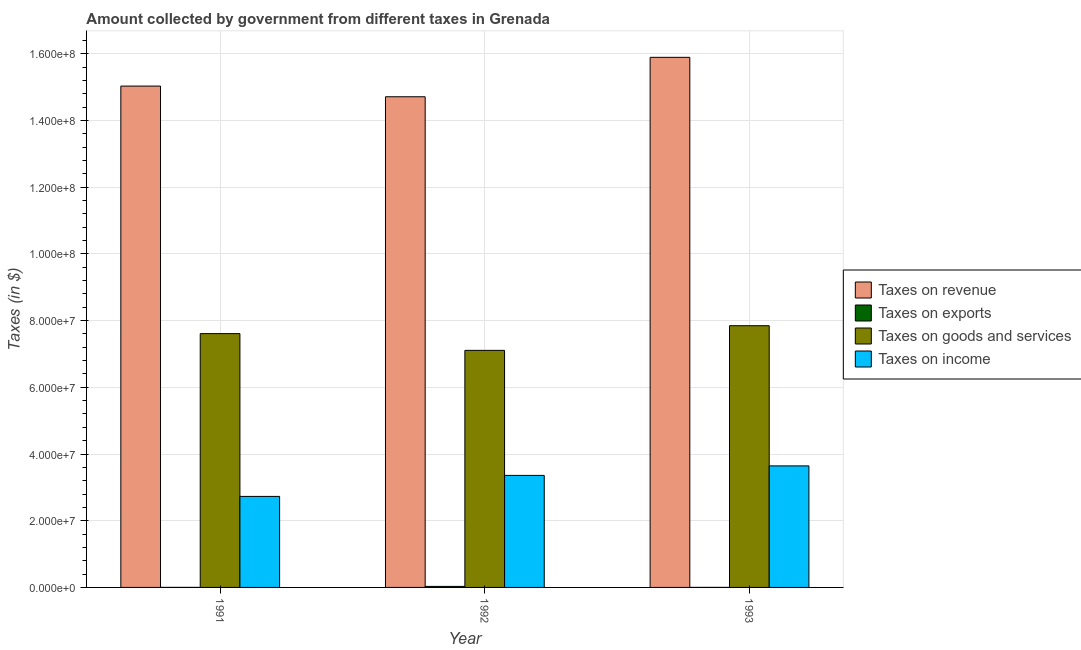How many different coloured bars are there?
Keep it short and to the point. 4. How many bars are there on the 2nd tick from the right?
Your answer should be very brief. 4. In how many cases, is the number of bars for a given year not equal to the number of legend labels?
Your response must be concise. 0. What is the amount collected as tax on goods in 1993?
Your answer should be very brief. 7.85e+07. Across all years, what is the maximum amount collected as tax on goods?
Ensure brevity in your answer.  7.85e+07. Across all years, what is the minimum amount collected as tax on goods?
Provide a short and direct response. 7.11e+07. In which year was the amount collected as tax on income minimum?
Offer a very short reply. 1991. What is the total amount collected as tax on exports in the graph?
Offer a very short reply. 3.30e+05. What is the difference between the amount collected as tax on goods in 1991 and that in 1993?
Offer a very short reply. -2.37e+06. What is the difference between the amount collected as tax on income in 1992 and the amount collected as tax on goods in 1993?
Ensure brevity in your answer.  -2.85e+06. What is the average amount collected as tax on revenue per year?
Keep it short and to the point. 1.52e+08. In how many years, is the amount collected as tax on revenue greater than 120000000 $?
Make the answer very short. 3. What is the ratio of the amount collected as tax on exports in 1991 to that in 1993?
Give a very brief answer. 1. Is the difference between the amount collected as tax on revenue in 1991 and 1992 greater than the difference between the amount collected as tax on exports in 1991 and 1992?
Keep it short and to the point. No. What is the difference between the highest and the lowest amount collected as tax on income?
Your response must be concise. 9.15e+06. In how many years, is the amount collected as tax on goods greater than the average amount collected as tax on goods taken over all years?
Your answer should be very brief. 2. What does the 4th bar from the left in 1993 represents?
Keep it short and to the point. Taxes on income. What does the 3rd bar from the right in 1992 represents?
Keep it short and to the point. Taxes on exports. How many bars are there?
Offer a very short reply. 12. Does the graph contain grids?
Provide a succinct answer. Yes. What is the title of the graph?
Provide a succinct answer. Amount collected by government from different taxes in Grenada. What is the label or title of the X-axis?
Your answer should be compact. Year. What is the label or title of the Y-axis?
Your response must be concise. Taxes (in $). What is the Taxes (in $) in Taxes on revenue in 1991?
Provide a succinct answer. 1.50e+08. What is the Taxes (in $) in Taxes on exports in 1991?
Provide a succinct answer. 10000. What is the Taxes (in $) in Taxes on goods and services in 1991?
Your answer should be very brief. 7.61e+07. What is the Taxes (in $) in Taxes on income in 1991?
Give a very brief answer. 2.73e+07. What is the Taxes (in $) of Taxes on revenue in 1992?
Your response must be concise. 1.47e+08. What is the Taxes (in $) of Taxes on goods and services in 1992?
Offer a very short reply. 7.11e+07. What is the Taxes (in $) in Taxes on income in 1992?
Provide a short and direct response. 3.36e+07. What is the Taxes (in $) of Taxes on revenue in 1993?
Keep it short and to the point. 1.59e+08. What is the Taxes (in $) of Taxes on exports in 1993?
Provide a succinct answer. 10000. What is the Taxes (in $) in Taxes on goods and services in 1993?
Keep it short and to the point. 7.85e+07. What is the Taxes (in $) in Taxes on income in 1993?
Offer a very short reply. 3.64e+07. Across all years, what is the maximum Taxes (in $) in Taxes on revenue?
Give a very brief answer. 1.59e+08. Across all years, what is the maximum Taxes (in $) of Taxes on exports?
Keep it short and to the point. 3.10e+05. Across all years, what is the maximum Taxes (in $) in Taxes on goods and services?
Offer a terse response. 7.85e+07. Across all years, what is the maximum Taxes (in $) in Taxes on income?
Provide a succinct answer. 3.64e+07. Across all years, what is the minimum Taxes (in $) in Taxes on revenue?
Offer a very short reply. 1.47e+08. Across all years, what is the minimum Taxes (in $) of Taxes on goods and services?
Provide a succinct answer. 7.11e+07. Across all years, what is the minimum Taxes (in $) of Taxes on income?
Make the answer very short. 2.73e+07. What is the total Taxes (in $) of Taxes on revenue in the graph?
Provide a succinct answer. 4.56e+08. What is the total Taxes (in $) in Taxes on goods and services in the graph?
Your answer should be compact. 2.26e+08. What is the total Taxes (in $) in Taxes on income in the graph?
Give a very brief answer. 9.73e+07. What is the difference between the Taxes (in $) of Taxes on revenue in 1991 and that in 1992?
Your answer should be compact. 3.20e+06. What is the difference between the Taxes (in $) in Taxes on exports in 1991 and that in 1992?
Offer a terse response. -3.00e+05. What is the difference between the Taxes (in $) in Taxes on goods and services in 1991 and that in 1992?
Your answer should be very brief. 5.02e+06. What is the difference between the Taxes (in $) in Taxes on income in 1991 and that in 1992?
Ensure brevity in your answer.  -6.30e+06. What is the difference between the Taxes (in $) in Taxes on revenue in 1991 and that in 1993?
Provide a short and direct response. -8.62e+06. What is the difference between the Taxes (in $) of Taxes on exports in 1991 and that in 1993?
Your response must be concise. 0. What is the difference between the Taxes (in $) of Taxes on goods and services in 1991 and that in 1993?
Give a very brief answer. -2.37e+06. What is the difference between the Taxes (in $) in Taxes on income in 1991 and that in 1993?
Your answer should be very brief. -9.15e+06. What is the difference between the Taxes (in $) of Taxes on revenue in 1992 and that in 1993?
Provide a succinct answer. -1.18e+07. What is the difference between the Taxes (in $) in Taxes on exports in 1992 and that in 1993?
Keep it short and to the point. 3.00e+05. What is the difference between the Taxes (in $) in Taxes on goods and services in 1992 and that in 1993?
Make the answer very short. -7.39e+06. What is the difference between the Taxes (in $) in Taxes on income in 1992 and that in 1993?
Offer a terse response. -2.85e+06. What is the difference between the Taxes (in $) of Taxes on revenue in 1991 and the Taxes (in $) of Taxes on exports in 1992?
Offer a terse response. 1.50e+08. What is the difference between the Taxes (in $) of Taxes on revenue in 1991 and the Taxes (in $) of Taxes on goods and services in 1992?
Make the answer very short. 7.92e+07. What is the difference between the Taxes (in $) in Taxes on revenue in 1991 and the Taxes (in $) in Taxes on income in 1992?
Ensure brevity in your answer.  1.17e+08. What is the difference between the Taxes (in $) of Taxes on exports in 1991 and the Taxes (in $) of Taxes on goods and services in 1992?
Ensure brevity in your answer.  -7.11e+07. What is the difference between the Taxes (in $) in Taxes on exports in 1991 and the Taxes (in $) in Taxes on income in 1992?
Ensure brevity in your answer.  -3.36e+07. What is the difference between the Taxes (in $) in Taxes on goods and services in 1991 and the Taxes (in $) in Taxes on income in 1992?
Provide a short and direct response. 4.25e+07. What is the difference between the Taxes (in $) of Taxes on revenue in 1991 and the Taxes (in $) of Taxes on exports in 1993?
Your response must be concise. 1.50e+08. What is the difference between the Taxes (in $) in Taxes on revenue in 1991 and the Taxes (in $) in Taxes on goods and services in 1993?
Make the answer very short. 7.18e+07. What is the difference between the Taxes (in $) in Taxes on revenue in 1991 and the Taxes (in $) in Taxes on income in 1993?
Keep it short and to the point. 1.14e+08. What is the difference between the Taxes (in $) of Taxes on exports in 1991 and the Taxes (in $) of Taxes on goods and services in 1993?
Make the answer very short. -7.85e+07. What is the difference between the Taxes (in $) of Taxes on exports in 1991 and the Taxes (in $) of Taxes on income in 1993?
Offer a terse response. -3.64e+07. What is the difference between the Taxes (in $) of Taxes on goods and services in 1991 and the Taxes (in $) of Taxes on income in 1993?
Provide a short and direct response. 3.97e+07. What is the difference between the Taxes (in $) in Taxes on revenue in 1992 and the Taxes (in $) in Taxes on exports in 1993?
Offer a very short reply. 1.47e+08. What is the difference between the Taxes (in $) in Taxes on revenue in 1992 and the Taxes (in $) in Taxes on goods and services in 1993?
Offer a very short reply. 6.86e+07. What is the difference between the Taxes (in $) in Taxes on revenue in 1992 and the Taxes (in $) in Taxes on income in 1993?
Give a very brief answer. 1.11e+08. What is the difference between the Taxes (in $) in Taxes on exports in 1992 and the Taxes (in $) in Taxes on goods and services in 1993?
Your response must be concise. -7.82e+07. What is the difference between the Taxes (in $) in Taxes on exports in 1992 and the Taxes (in $) in Taxes on income in 1993?
Provide a short and direct response. -3.61e+07. What is the difference between the Taxes (in $) in Taxes on goods and services in 1992 and the Taxes (in $) in Taxes on income in 1993?
Offer a very short reply. 3.46e+07. What is the average Taxes (in $) of Taxes on revenue per year?
Provide a short and direct response. 1.52e+08. What is the average Taxes (in $) in Taxes on goods and services per year?
Provide a short and direct response. 7.52e+07. What is the average Taxes (in $) in Taxes on income per year?
Keep it short and to the point. 3.24e+07. In the year 1991, what is the difference between the Taxes (in $) of Taxes on revenue and Taxes (in $) of Taxes on exports?
Keep it short and to the point. 1.50e+08. In the year 1991, what is the difference between the Taxes (in $) in Taxes on revenue and Taxes (in $) in Taxes on goods and services?
Provide a succinct answer. 7.42e+07. In the year 1991, what is the difference between the Taxes (in $) of Taxes on revenue and Taxes (in $) of Taxes on income?
Your response must be concise. 1.23e+08. In the year 1991, what is the difference between the Taxes (in $) in Taxes on exports and Taxes (in $) in Taxes on goods and services?
Offer a very short reply. -7.61e+07. In the year 1991, what is the difference between the Taxes (in $) of Taxes on exports and Taxes (in $) of Taxes on income?
Your response must be concise. -2.73e+07. In the year 1991, what is the difference between the Taxes (in $) of Taxes on goods and services and Taxes (in $) of Taxes on income?
Give a very brief answer. 4.88e+07. In the year 1992, what is the difference between the Taxes (in $) of Taxes on revenue and Taxes (in $) of Taxes on exports?
Your answer should be very brief. 1.47e+08. In the year 1992, what is the difference between the Taxes (in $) of Taxes on revenue and Taxes (in $) of Taxes on goods and services?
Ensure brevity in your answer.  7.60e+07. In the year 1992, what is the difference between the Taxes (in $) of Taxes on revenue and Taxes (in $) of Taxes on income?
Provide a short and direct response. 1.14e+08. In the year 1992, what is the difference between the Taxes (in $) in Taxes on exports and Taxes (in $) in Taxes on goods and services?
Your response must be concise. -7.08e+07. In the year 1992, what is the difference between the Taxes (in $) in Taxes on exports and Taxes (in $) in Taxes on income?
Your answer should be very brief. -3.33e+07. In the year 1992, what is the difference between the Taxes (in $) of Taxes on goods and services and Taxes (in $) of Taxes on income?
Provide a succinct answer. 3.75e+07. In the year 1993, what is the difference between the Taxes (in $) of Taxes on revenue and Taxes (in $) of Taxes on exports?
Your response must be concise. 1.59e+08. In the year 1993, what is the difference between the Taxes (in $) in Taxes on revenue and Taxes (in $) in Taxes on goods and services?
Your response must be concise. 8.05e+07. In the year 1993, what is the difference between the Taxes (in $) in Taxes on revenue and Taxes (in $) in Taxes on income?
Your response must be concise. 1.22e+08. In the year 1993, what is the difference between the Taxes (in $) of Taxes on exports and Taxes (in $) of Taxes on goods and services?
Provide a short and direct response. -7.85e+07. In the year 1993, what is the difference between the Taxes (in $) in Taxes on exports and Taxes (in $) in Taxes on income?
Provide a succinct answer. -3.64e+07. In the year 1993, what is the difference between the Taxes (in $) in Taxes on goods and services and Taxes (in $) in Taxes on income?
Ensure brevity in your answer.  4.20e+07. What is the ratio of the Taxes (in $) of Taxes on revenue in 1991 to that in 1992?
Your response must be concise. 1.02. What is the ratio of the Taxes (in $) in Taxes on exports in 1991 to that in 1992?
Your response must be concise. 0.03. What is the ratio of the Taxes (in $) of Taxes on goods and services in 1991 to that in 1992?
Keep it short and to the point. 1.07. What is the ratio of the Taxes (in $) of Taxes on income in 1991 to that in 1992?
Your response must be concise. 0.81. What is the ratio of the Taxes (in $) of Taxes on revenue in 1991 to that in 1993?
Give a very brief answer. 0.95. What is the ratio of the Taxes (in $) of Taxes on goods and services in 1991 to that in 1993?
Offer a very short reply. 0.97. What is the ratio of the Taxes (in $) of Taxes on income in 1991 to that in 1993?
Ensure brevity in your answer.  0.75. What is the ratio of the Taxes (in $) in Taxes on revenue in 1992 to that in 1993?
Make the answer very short. 0.93. What is the ratio of the Taxes (in $) in Taxes on exports in 1992 to that in 1993?
Give a very brief answer. 31. What is the ratio of the Taxes (in $) of Taxes on goods and services in 1992 to that in 1993?
Make the answer very short. 0.91. What is the ratio of the Taxes (in $) in Taxes on income in 1992 to that in 1993?
Ensure brevity in your answer.  0.92. What is the difference between the highest and the second highest Taxes (in $) in Taxes on revenue?
Offer a terse response. 8.62e+06. What is the difference between the highest and the second highest Taxes (in $) in Taxes on goods and services?
Provide a short and direct response. 2.37e+06. What is the difference between the highest and the second highest Taxes (in $) in Taxes on income?
Ensure brevity in your answer.  2.85e+06. What is the difference between the highest and the lowest Taxes (in $) of Taxes on revenue?
Provide a short and direct response. 1.18e+07. What is the difference between the highest and the lowest Taxes (in $) of Taxes on goods and services?
Make the answer very short. 7.39e+06. What is the difference between the highest and the lowest Taxes (in $) in Taxes on income?
Make the answer very short. 9.15e+06. 